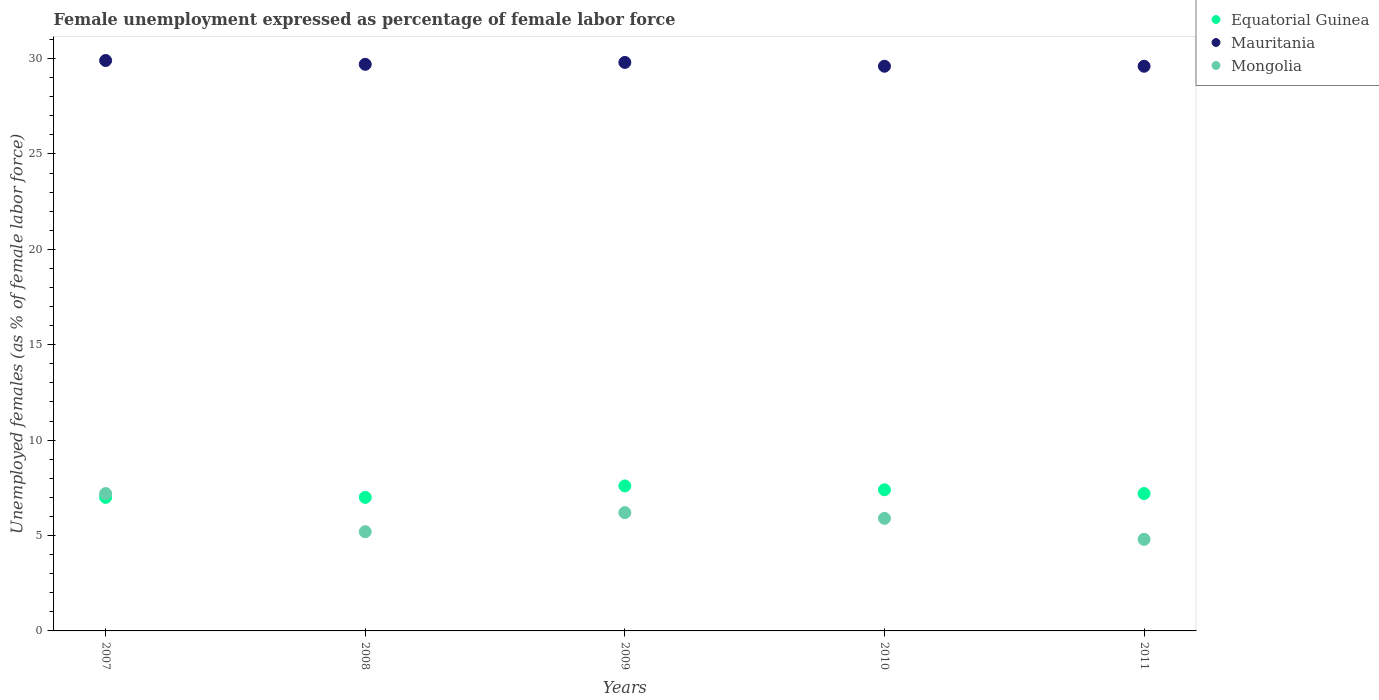How many different coloured dotlines are there?
Your response must be concise. 3. What is the unemployment in females in in Equatorial Guinea in 2010?
Offer a terse response. 7.4. Across all years, what is the maximum unemployment in females in in Mongolia?
Your answer should be compact. 7.2. In which year was the unemployment in females in in Mongolia maximum?
Offer a very short reply. 2007. In which year was the unemployment in females in in Mongolia minimum?
Your answer should be compact. 2011. What is the total unemployment in females in in Mongolia in the graph?
Keep it short and to the point. 29.3. What is the difference between the unemployment in females in in Equatorial Guinea in 2007 and that in 2011?
Make the answer very short. -0.2. What is the difference between the unemployment in females in in Mauritania in 2010 and the unemployment in females in in Equatorial Guinea in 2007?
Make the answer very short. 22.6. What is the average unemployment in females in in Mauritania per year?
Keep it short and to the point. 29.72. In the year 2009, what is the difference between the unemployment in females in in Mongolia and unemployment in females in in Mauritania?
Ensure brevity in your answer.  -23.6. What is the ratio of the unemployment in females in in Mauritania in 2009 to that in 2010?
Your response must be concise. 1.01. Is the unemployment in females in in Mongolia in 2008 less than that in 2011?
Make the answer very short. No. What is the difference between the highest and the second highest unemployment in females in in Mauritania?
Your response must be concise. 0.1. What is the difference between the highest and the lowest unemployment in females in in Mongolia?
Offer a very short reply. 2.4. Is the sum of the unemployment in females in in Equatorial Guinea in 2007 and 2009 greater than the maximum unemployment in females in in Mongolia across all years?
Give a very brief answer. Yes. Is the unemployment in females in in Mongolia strictly greater than the unemployment in females in in Equatorial Guinea over the years?
Ensure brevity in your answer.  No. Is the unemployment in females in in Mauritania strictly less than the unemployment in females in in Mongolia over the years?
Your answer should be very brief. No. How many dotlines are there?
Provide a short and direct response. 3. Does the graph contain any zero values?
Give a very brief answer. No. How many legend labels are there?
Your answer should be compact. 3. How are the legend labels stacked?
Provide a short and direct response. Vertical. What is the title of the graph?
Ensure brevity in your answer.  Female unemployment expressed as percentage of female labor force. Does "Senegal" appear as one of the legend labels in the graph?
Give a very brief answer. No. What is the label or title of the X-axis?
Your response must be concise. Years. What is the label or title of the Y-axis?
Keep it short and to the point. Unemployed females (as % of female labor force). What is the Unemployed females (as % of female labor force) of Mauritania in 2007?
Make the answer very short. 29.9. What is the Unemployed females (as % of female labor force) in Mongolia in 2007?
Provide a short and direct response. 7.2. What is the Unemployed females (as % of female labor force) of Mauritania in 2008?
Keep it short and to the point. 29.7. What is the Unemployed females (as % of female labor force) in Mongolia in 2008?
Give a very brief answer. 5.2. What is the Unemployed females (as % of female labor force) of Equatorial Guinea in 2009?
Ensure brevity in your answer.  7.6. What is the Unemployed females (as % of female labor force) in Mauritania in 2009?
Ensure brevity in your answer.  29.8. What is the Unemployed females (as % of female labor force) of Mongolia in 2009?
Give a very brief answer. 6.2. What is the Unemployed females (as % of female labor force) in Equatorial Guinea in 2010?
Your response must be concise. 7.4. What is the Unemployed females (as % of female labor force) in Mauritania in 2010?
Offer a terse response. 29.6. What is the Unemployed females (as % of female labor force) in Mongolia in 2010?
Offer a very short reply. 5.9. What is the Unemployed females (as % of female labor force) in Equatorial Guinea in 2011?
Your response must be concise. 7.2. What is the Unemployed females (as % of female labor force) in Mauritania in 2011?
Offer a terse response. 29.6. What is the Unemployed females (as % of female labor force) in Mongolia in 2011?
Your answer should be compact. 4.8. Across all years, what is the maximum Unemployed females (as % of female labor force) in Equatorial Guinea?
Provide a succinct answer. 7.6. Across all years, what is the maximum Unemployed females (as % of female labor force) in Mauritania?
Make the answer very short. 29.9. Across all years, what is the maximum Unemployed females (as % of female labor force) of Mongolia?
Make the answer very short. 7.2. Across all years, what is the minimum Unemployed females (as % of female labor force) of Equatorial Guinea?
Keep it short and to the point. 7. Across all years, what is the minimum Unemployed females (as % of female labor force) in Mauritania?
Offer a terse response. 29.6. Across all years, what is the minimum Unemployed females (as % of female labor force) in Mongolia?
Ensure brevity in your answer.  4.8. What is the total Unemployed females (as % of female labor force) in Equatorial Guinea in the graph?
Your response must be concise. 36.2. What is the total Unemployed females (as % of female labor force) in Mauritania in the graph?
Your answer should be compact. 148.6. What is the total Unemployed females (as % of female labor force) of Mongolia in the graph?
Your answer should be very brief. 29.3. What is the difference between the Unemployed females (as % of female labor force) in Mauritania in 2007 and that in 2008?
Make the answer very short. 0.2. What is the difference between the Unemployed females (as % of female labor force) in Equatorial Guinea in 2007 and that in 2009?
Provide a short and direct response. -0.6. What is the difference between the Unemployed females (as % of female labor force) of Mauritania in 2007 and that in 2009?
Ensure brevity in your answer.  0.1. What is the difference between the Unemployed females (as % of female labor force) in Mongolia in 2007 and that in 2009?
Provide a short and direct response. 1. What is the difference between the Unemployed females (as % of female labor force) in Equatorial Guinea in 2007 and that in 2010?
Provide a succinct answer. -0.4. What is the difference between the Unemployed females (as % of female labor force) of Mauritania in 2007 and that in 2011?
Your answer should be compact. 0.3. What is the difference between the Unemployed females (as % of female labor force) in Mauritania in 2008 and that in 2009?
Ensure brevity in your answer.  -0.1. What is the difference between the Unemployed females (as % of female labor force) in Mongolia in 2008 and that in 2009?
Offer a very short reply. -1. What is the difference between the Unemployed females (as % of female labor force) of Mauritania in 2008 and that in 2010?
Your response must be concise. 0.1. What is the difference between the Unemployed females (as % of female labor force) of Mongolia in 2008 and that in 2010?
Provide a succinct answer. -0.7. What is the difference between the Unemployed females (as % of female labor force) in Mauritania in 2008 and that in 2011?
Give a very brief answer. 0.1. What is the difference between the Unemployed females (as % of female labor force) of Mauritania in 2009 and that in 2011?
Keep it short and to the point. 0.2. What is the difference between the Unemployed females (as % of female labor force) in Equatorial Guinea in 2010 and that in 2011?
Provide a short and direct response. 0.2. What is the difference between the Unemployed females (as % of female labor force) in Mauritania in 2010 and that in 2011?
Your response must be concise. 0. What is the difference between the Unemployed females (as % of female labor force) in Mongolia in 2010 and that in 2011?
Provide a short and direct response. 1.1. What is the difference between the Unemployed females (as % of female labor force) in Equatorial Guinea in 2007 and the Unemployed females (as % of female labor force) in Mauritania in 2008?
Provide a short and direct response. -22.7. What is the difference between the Unemployed females (as % of female labor force) of Equatorial Guinea in 2007 and the Unemployed females (as % of female labor force) of Mongolia in 2008?
Make the answer very short. 1.8. What is the difference between the Unemployed females (as % of female labor force) in Mauritania in 2007 and the Unemployed females (as % of female labor force) in Mongolia in 2008?
Offer a very short reply. 24.7. What is the difference between the Unemployed females (as % of female labor force) in Equatorial Guinea in 2007 and the Unemployed females (as % of female labor force) in Mauritania in 2009?
Ensure brevity in your answer.  -22.8. What is the difference between the Unemployed females (as % of female labor force) in Mauritania in 2007 and the Unemployed females (as % of female labor force) in Mongolia in 2009?
Offer a very short reply. 23.7. What is the difference between the Unemployed females (as % of female labor force) of Equatorial Guinea in 2007 and the Unemployed females (as % of female labor force) of Mauritania in 2010?
Make the answer very short. -22.6. What is the difference between the Unemployed females (as % of female labor force) of Mauritania in 2007 and the Unemployed females (as % of female labor force) of Mongolia in 2010?
Your response must be concise. 24. What is the difference between the Unemployed females (as % of female labor force) in Equatorial Guinea in 2007 and the Unemployed females (as % of female labor force) in Mauritania in 2011?
Provide a short and direct response. -22.6. What is the difference between the Unemployed females (as % of female labor force) of Mauritania in 2007 and the Unemployed females (as % of female labor force) of Mongolia in 2011?
Offer a terse response. 25.1. What is the difference between the Unemployed females (as % of female labor force) in Equatorial Guinea in 2008 and the Unemployed females (as % of female labor force) in Mauritania in 2009?
Provide a short and direct response. -22.8. What is the difference between the Unemployed females (as % of female labor force) in Mauritania in 2008 and the Unemployed females (as % of female labor force) in Mongolia in 2009?
Give a very brief answer. 23.5. What is the difference between the Unemployed females (as % of female labor force) of Equatorial Guinea in 2008 and the Unemployed females (as % of female labor force) of Mauritania in 2010?
Your answer should be very brief. -22.6. What is the difference between the Unemployed females (as % of female labor force) of Mauritania in 2008 and the Unemployed females (as % of female labor force) of Mongolia in 2010?
Make the answer very short. 23.8. What is the difference between the Unemployed females (as % of female labor force) in Equatorial Guinea in 2008 and the Unemployed females (as % of female labor force) in Mauritania in 2011?
Offer a very short reply. -22.6. What is the difference between the Unemployed females (as % of female labor force) in Equatorial Guinea in 2008 and the Unemployed females (as % of female labor force) in Mongolia in 2011?
Give a very brief answer. 2.2. What is the difference between the Unemployed females (as % of female labor force) of Mauritania in 2008 and the Unemployed females (as % of female labor force) of Mongolia in 2011?
Provide a short and direct response. 24.9. What is the difference between the Unemployed females (as % of female labor force) in Equatorial Guinea in 2009 and the Unemployed females (as % of female labor force) in Mauritania in 2010?
Make the answer very short. -22. What is the difference between the Unemployed females (as % of female labor force) of Equatorial Guinea in 2009 and the Unemployed females (as % of female labor force) of Mongolia in 2010?
Offer a terse response. 1.7. What is the difference between the Unemployed females (as % of female labor force) of Mauritania in 2009 and the Unemployed females (as % of female labor force) of Mongolia in 2010?
Provide a succinct answer. 23.9. What is the difference between the Unemployed females (as % of female labor force) of Equatorial Guinea in 2009 and the Unemployed females (as % of female labor force) of Mauritania in 2011?
Give a very brief answer. -22. What is the difference between the Unemployed females (as % of female labor force) of Equatorial Guinea in 2009 and the Unemployed females (as % of female labor force) of Mongolia in 2011?
Make the answer very short. 2.8. What is the difference between the Unemployed females (as % of female labor force) in Equatorial Guinea in 2010 and the Unemployed females (as % of female labor force) in Mauritania in 2011?
Ensure brevity in your answer.  -22.2. What is the difference between the Unemployed females (as % of female labor force) of Mauritania in 2010 and the Unemployed females (as % of female labor force) of Mongolia in 2011?
Give a very brief answer. 24.8. What is the average Unemployed females (as % of female labor force) in Equatorial Guinea per year?
Your response must be concise. 7.24. What is the average Unemployed females (as % of female labor force) in Mauritania per year?
Provide a short and direct response. 29.72. What is the average Unemployed females (as % of female labor force) in Mongolia per year?
Your answer should be compact. 5.86. In the year 2007, what is the difference between the Unemployed females (as % of female labor force) in Equatorial Guinea and Unemployed females (as % of female labor force) in Mauritania?
Provide a short and direct response. -22.9. In the year 2007, what is the difference between the Unemployed females (as % of female labor force) of Equatorial Guinea and Unemployed females (as % of female labor force) of Mongolia?
Offer a terse response. -0.2. In the year 2007, what is the difference between the Unemployed females (as % of female labor force) in Mauritania and Unemployed females (as % of female labor force) in Mongolia?
Your answer should be very brief. 22.7. In the year 2008, what is the difference between the Unemployed females (as % of female labor force) of Equatorial Guinea and Unemployed females (as % of female labor force) of Mauritania?
Your answer should be compact. -22.7. In the year 2008, what is the difference between the Unemployed females (as % of female labor force) of Equatorial Guinea and Unemployed females (as % of female labor force) of Mongolia?
Your answer should be compact. 1.8. In the year 2008, what is the difference between the Unemployed females (as % of female labor force) in Mauritania and Unemployed females (as % of female labor force) in Mongolia?
Keep it short and to the point. 24.5. In the year 2009, what is the difference between the Unemployed females (as % of female labor force) in Equatorial Guinea and Unemployed females (as % of female labor force) in Mauritania?
Ensure brevity in your answer.  -22.2. In the year 2009, what is the difference between the Unemployed females (as % of female labor force) of Mauritania and Unemployed females (as % of female labor force) of Mongolia?
Offer a very short reply. 23.6. In the year 2010, what is the difference between the Unemployed females (as % of female labor force) of Equatorial Guinea and Unemployed females (as % of female labor force) of Mauritania?
Provide a succinct answer. -22.2. In the year 2010, what is the difference between the Unemployed females (as % of female labor force) in Equatorial Guinea and Unemployed females (as % of female labor force) in Mongolia?
Provide a short and direct response. 1.5. In the year 2010, what is the difference between the Unemployed females (as % of female labor force) of Mauritania and Unemployed females (as % of female labor force) of Mongolia?
Your answer should be compact. 23.7. In the year 2011, what is the difference between the Unemployed females (as % of female labor force) of Equatorial Guinea and Unemployed females (as % of female labor force) of Mauritania?
Keep it short and to the point. -22.4. In the year 2011, what is the difference between the Unemployed females (as % of female labor force) in Equatorial Guinea and Unemployed females (as % of female labor force) in Mongolia?
Your answer should be very brief. 2.4. In the year 2011, what is the difference between the Unemployed females (as % of female labor force) of Mauritania and Unemployed females (as % of female labor force) of Mongolia?
Provide a short and direct response. 24.8. What is the ratio of the Unemployed females (as % of female labor force) of Mauritania in 2007 to that in 2008?
Keep it short and to the point. 1.01. What is the ratio of the Unemployed females (as % of female labor force) in Mongolia in 2007 to that in 2008?
Give a very brief answer. 1.38. What is the ratio of the Unemployed females (as % of female labor force) of Equatorial Guinea in 2007 to that in 2009?
Keep it short and to the point. 0.92. What is the ratio of the Unemployed females (as % of female labor force) of Mongolia in 2007 to that in 2009?
Provide a short and direct response. 1.16. What is the ratio of the Unemployed females (as % of female labor force) in Equatorial Guinea in 2007 to that in 2010?
Your answer should be very brief. 0.95. What is the ratio of the Unemployed females (as % of female labor force) in Mauritania in 2007 to that in 2010?
Give a very brief answer. 1.01. What is the ratio of the Unemployed females (as % of female labor force) in Mongolia in 2007 to that in 2010?
Your response must be concise. 1.22. What is the ratio of the Unemployed females (as % of female labor force) of Equatorial Guinea in 2007 to that in 2011?
Offer a terse response. 0.97. What is the ratio of the Unemployed females (as % of female labor force) in Mauritania in 2007 to that in 2011?
Your answer should be compact. 1.01. What is the ratio of the Unemployed females (as % of female labor force) of Equatorial Guinea in 2008 to that in 2009?
Provide a succinct answer. 0.92. What is the ratio of the Unemployed females (as % of female labor force) in Mauritania in 2008 to that in 2009?
Your answer should be compact. 1. What is the ratio of the Unemployed females (as % of female labor force) in Mongolia in 2008 to that in 2009?
Ensure brevity in your answer.  0.84. What is the ratio of the Unemployed females (as % of female labor force) in Equatorial Guinea in 2008 to that in 2010?
Provide a short and direct response. 0.95. What is the ratio of the Unemployed females (as % of female labor force) of Mauritania in 2008 to that in 2010?
Offer a very short reply. 1. What is the ratio of the Unemployed females (as % of female labor force) of Mongolia in 2008 to that in 2010?
Ensure brevity in your answer.  0.88. What is the ratio of the Unemployed females (as % of female labor force) in Equatorial Guinea in 2008 to that in 2011?
Make the answer very short. 0.97. What is the ratio of the Unemployed females (as % of female labor force) in Mauritania in 2008 to that in 2011?
Make the answer very short. 1. What is the ratio of the Unemployed females (as % of female labor force) of Mauritania in 2009 to that in 2010?
Keep it short and to the point. 1.01. What is the ratio of the Unemployed females (as % of female labor force) in Mongolia in 2009 to that in 2010?
Your answer should be compact. 1.05. What is the ratio of the Unemployed females (as % of female labor force) in Equatorial Guinea in 2009 to that in 2011?
Make the answer very short. 1.06. What is the ratio of the Unemployed females (as % of female labor force) in Mauritania in 2009 to that in 2011?
Provide a short and direct response. 1.01. What is the ratio of the Unemployed females (as % of female labor force) of Mongolia in 2009 to that in 2011?
Your answer should be compact. 1.29. What is the ratio of the Unemployed females (as % of female labor force) in Equatorial Guinea in 2010 to that in 2011?
Your response must be concise. 1.03. What is the ratio of the Unemployed females (as % of female labor force) in Mongolia in 2010 to that in 2011?
Offer a terse response. 1.23. What is the difference between the highest and the second highest Unemployed females (as % of female labor force) in Equatorial Guinea?
Ensure brevity in your answer.  0.2. What is the difference between the highest and the second highest Unemployed females (as % of female labor force) of Mauritania?
Your answer should be compact. 0.1. What is the difference between the highest and the lowest Unemployed females (as % of female labor force) of Mauritania?
Give a very brief answer. 0.3. What is the difference between the highest and the lowest Unemployed females (as % of female labor force) in Mongolia?
Offer a very short reply. 2.4. 